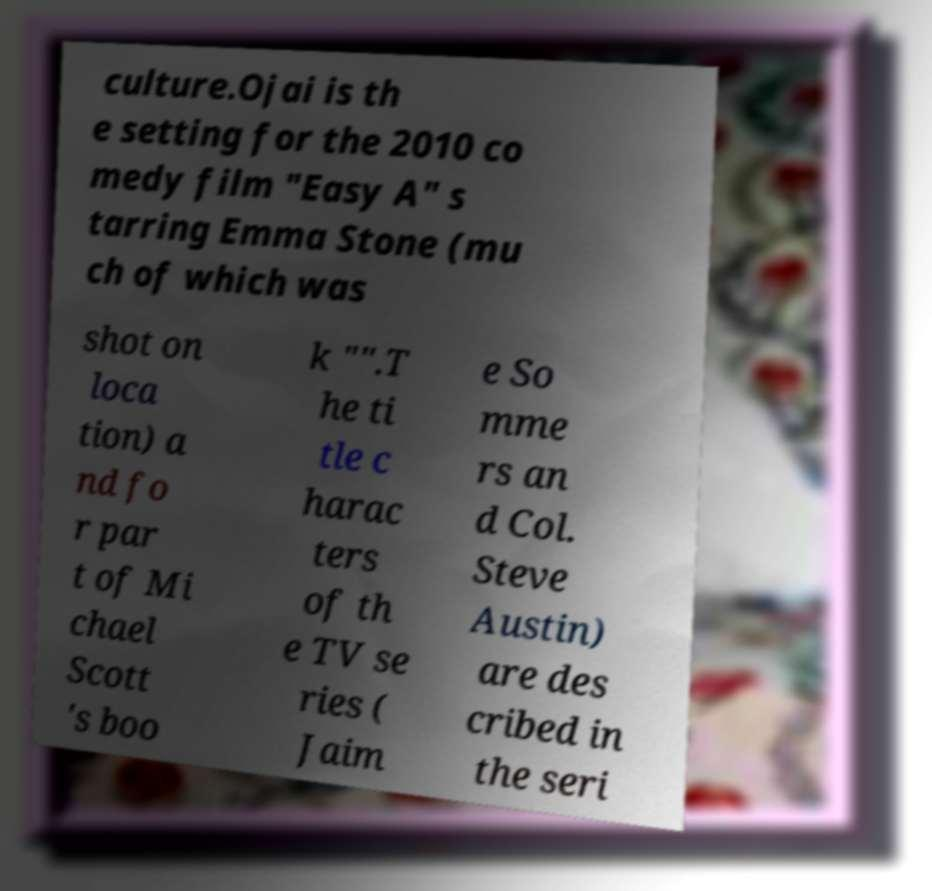Please read and relay the text visible in this image. What does it say? culture.Ojai is th e setting for the 2010 co medy film "Easy A" s tarring Emma Stone (mu ch of which was shot on loca tion) a nd fo r par t of Mi chael Scott 's boo k "".T he ti tle c harac ters of th e TV se ries ( Jaim e So mme rs an d Col. Steve Austin) are des cribed in the seri 